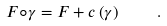<formula> <loc_0><loc_0><loc_500><loc_500>F \circ \gamma = F + c \left ( \gamma \right ) \quad .</formula> 